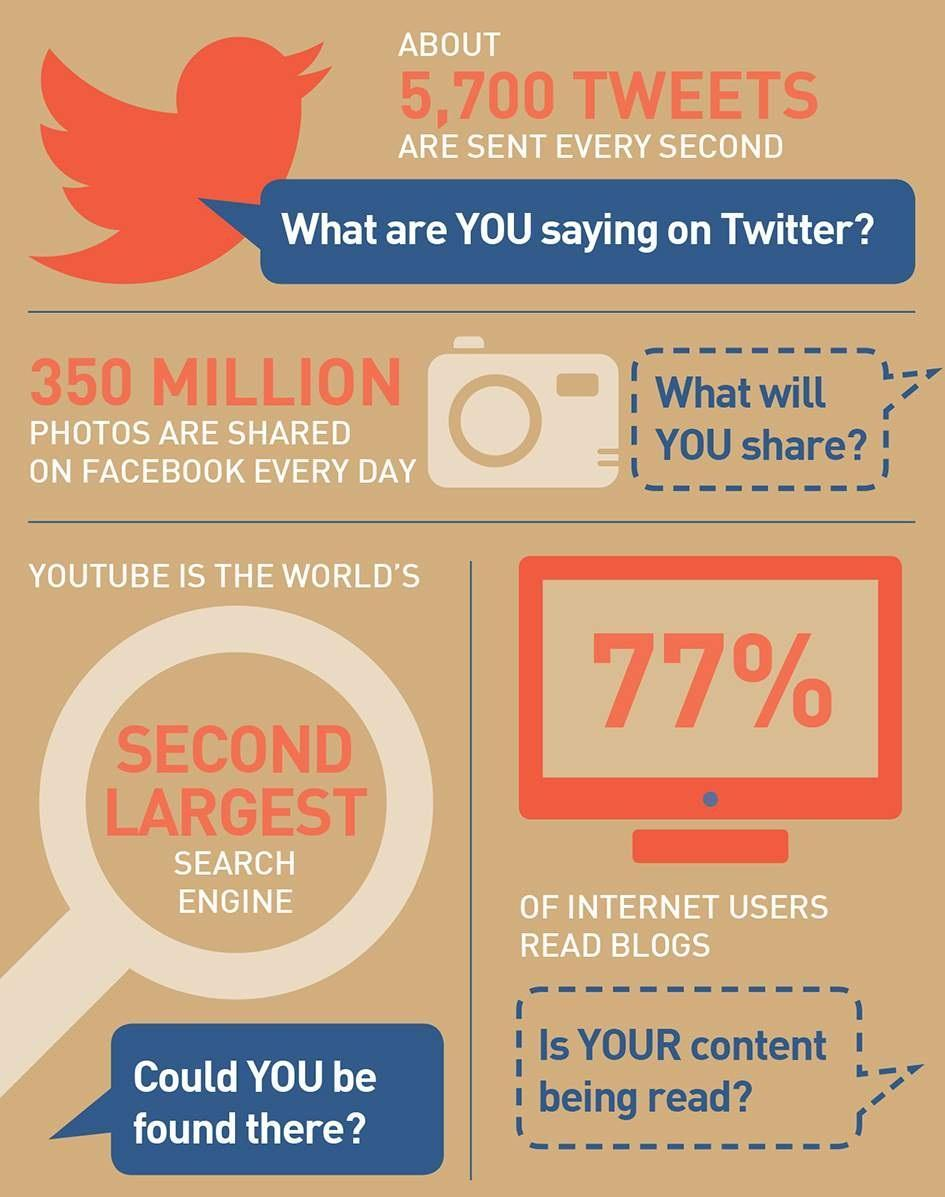What percentage of internet users do not read blogs?
Answer the question with a short phrase. 23% Which is the world's second largest search engine? YOUTUBE 